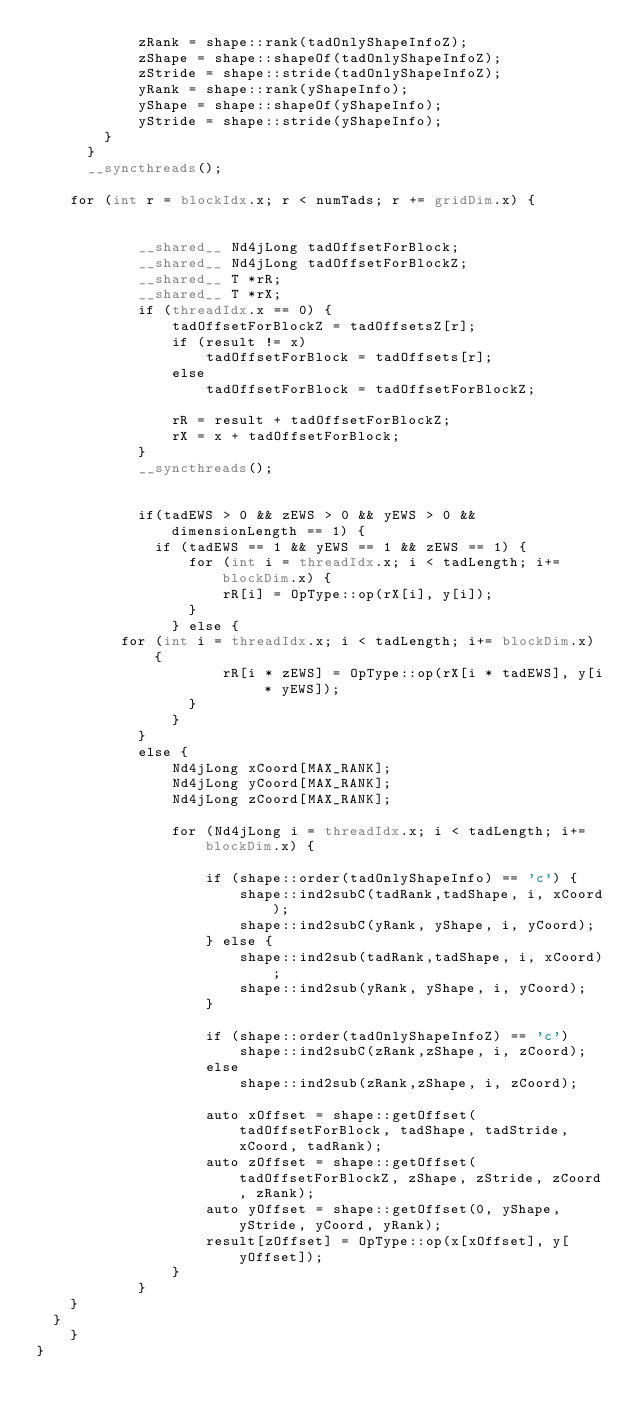<code> <loc_0><loc_0><loc_500><loc_500><_Cuda_>      	    zRank = shape::rank(tadOnlyShapeInfoZ);
      	    zShape = shape::shapeOf(tadOnlyShapeInfoZ);
      	    zStride = shape::stride(tadOnlyShapeInfoZ);
      	    yRank = shape::rank(yShapeInfo);
      	    yShape = shape::shapeOf(yShapeInfo);
      	    yStride = shape::stride(yShapeInfo);
        }
      }
      __syncthreads();

		for (int r = blockIdx.x; r < numTads; r += gridDim.x) {


            __shared__ Nd4jLong tadOffsetForBlock;
            __shared__ Nd4jLong tadOffsetForBlockZ;
            __shared__ T *rR;
            __shared__ T *rX;
            if (threadIdx.x == 0) {
                tadOffsetForBlockZ = tadOffsetsZ[r];
                if (result != x)
                    tadOffsetForBlock = tadOffsets[r];
                else
                    tadOffsetForBlock = tadOffsetForBlockZ;

                rR = result + tadOffsetForBlockZ;
                rX = x + tadOffsetForBlock;
            }
            __syncthreads();


            if(tadEWS > 0 && zEWS > 0 && yEWS > 0 && dimensionLength == 1) {
            	if (tadEWS == 1 && yEWS == 1 && zEWS == 1) {
                	for (int i = threadIdx.x; i < tadLength; i+= blockDim.x) {
                    	rR[i] = OpType::op(rX[i], y[i]);
                	}
                } else {
					for (int i = threadIdx.x; i < tadLength; i+= blockDim.x) {
                    	rR[i * zEWS] = OpType::op(rX[i * tadEWS], y[i * yEWS]);
                	}
                }
            }
            else {
                Nd4jLong xCoord[MAX_RANK];
                Nd4jLong yCoord[MAX_RANK];
                Nd4jLong zCoord[MAX_RANK];

                for (Nd4jLong i = threadIdx.x; i < tadLength; i+= blockDim.x) {

                    if (shape::order(tadOnlyShapeInfo) == 'c') {
                        shape::ind2subC(tadRank,tadShape, i, xCoord);
                        shape::ind2subC(yRank, yShape, i, yCoord);
                    } else {
                        shape::ind2sub(tadRank,tadShape, i, xCoord);
                        shape::ind2sub(yRank, yShape, i, yCoord);
                    }

                    if (shape::order(tadOnlyShapeInfoZ) == 'c')
                        shape::ind2subC(zRank,zShape, i, zCoord);
                    else
                        shape::ind2sub(zRank,zShape, i, zCoord);

                    auto xOffset = shape::getOffset(tadOffsetForBlock, tadShape, tadStride, xCoord, tadRank);
                    auto zOffset = shape::getOffset(tadOffsetForBlockZ, zShape, zStride, zCoord, zRank);
                    auto yOffset = shape::getOffset(0, yShape, yStride, yCoord, yRank);
                    result[zOffset] = OpType::op(x[xOffset], y[yOffset]);
                }
            }
		}
	}
    }
}</code> 